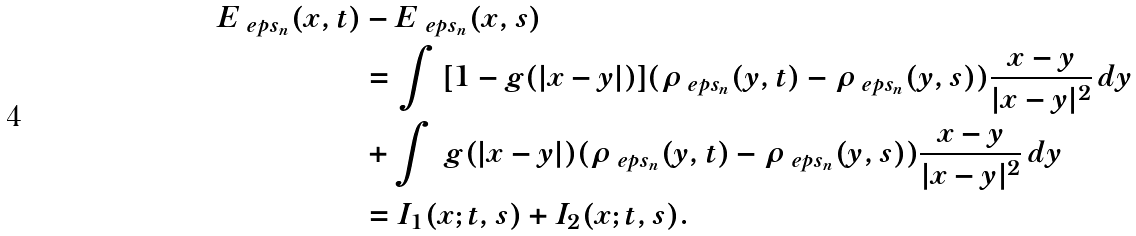Convert formula to latex. <formula><loc_0><loc_0><loc_500><loc_500>E _ { \ e p s _ { n } } ( x , t ) & - E _ { \ e p s _ { n } } ( x , s ) \\ & = \int \ [ 1 - g ( | x - y | ) ] ( \rho _ { \ e p s _ { n } } ( y , t ) - \rho _ { \ e p s _ { n } } ( y , s ) ) \frac { x - y } { | x - y | ^ { 2 } } \, d y \\ & + \int \ g ( | x - y | ) ( \rho _ { \ e p s _ { n } } ( y , t ) - \rho _ { \ e p s _ { n } } ( y , s ) ) \frac { x - y } { | x - y | ^ { 2 } } \, d y \\ & = I _ { 1 } ( x ; t , s ) + I _ { 2 } ( x ; t , s ) .</formula> 